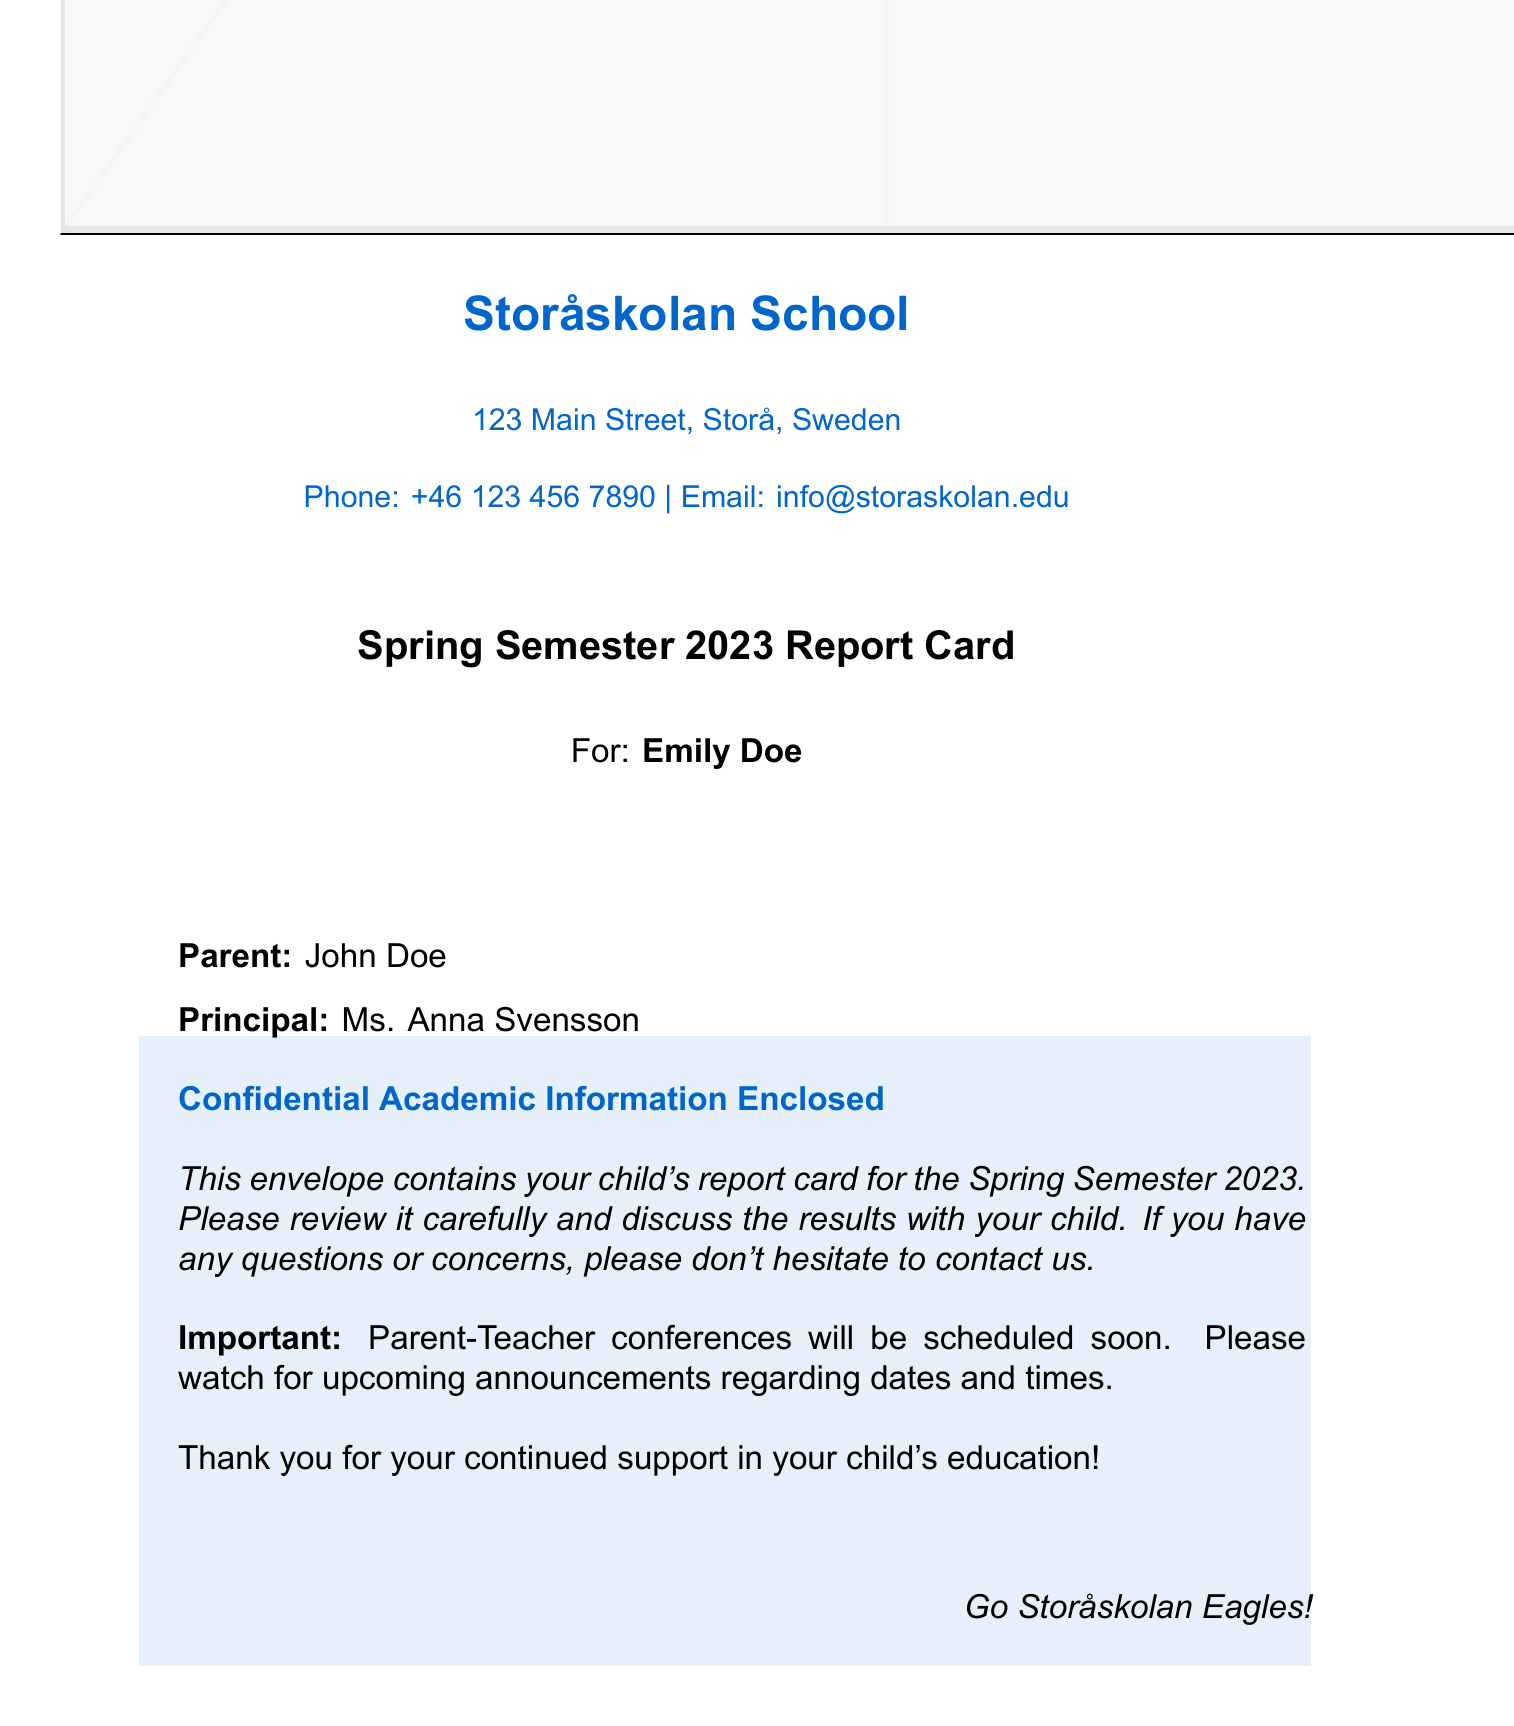What is the name of the student? The document contains the name of the student, which is specified as "Emily Doe."
Answer: Emily Doe Who is the parent of the student? The document mentions the parent's name, which is "John Doe."
Answer: John Doe What is the name of the principal? The document includes the principal's name, which is "Ms. Anna Svensson."
Answer: Ms. Anna Svensson What semester does this report card cover? The report card specifies that it is for the "Spring Semester 2023."
Answer: Spring Semester 2023 What is the phone number for Storåskolan School? The document provides the school's phone number as "+46 123 456 7890."
Answer: +46 123 456 7890 What should parents watch for regarding conferences? The document indicates that parents should "watch for upcoming announcements" related to conferences.
Answer: Upcoming announcements What was included in the envelope? The document states that the envelope contains "your child's report card."
Answer: Your child's report card What color is the background of the report card section? The document describes the background as "lightblue."
Answer: Lightblue What message is conveyed to the parents at the end of the document? The final message expresses gratitude for the parents' "continued support in your child's education."
Answer: Continued support in your child's education 